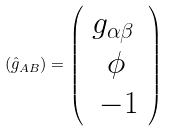<formula> <loc_0><loc_0><loc_500><loc_500>\left ( \hat { g } _ { A B } \right ) = \left ( \begin{array} { c c } g _ { \alpha \beta } \, \\ \, \phi \, \\ \, - 1 \\ \end{array} \right )</formula> 